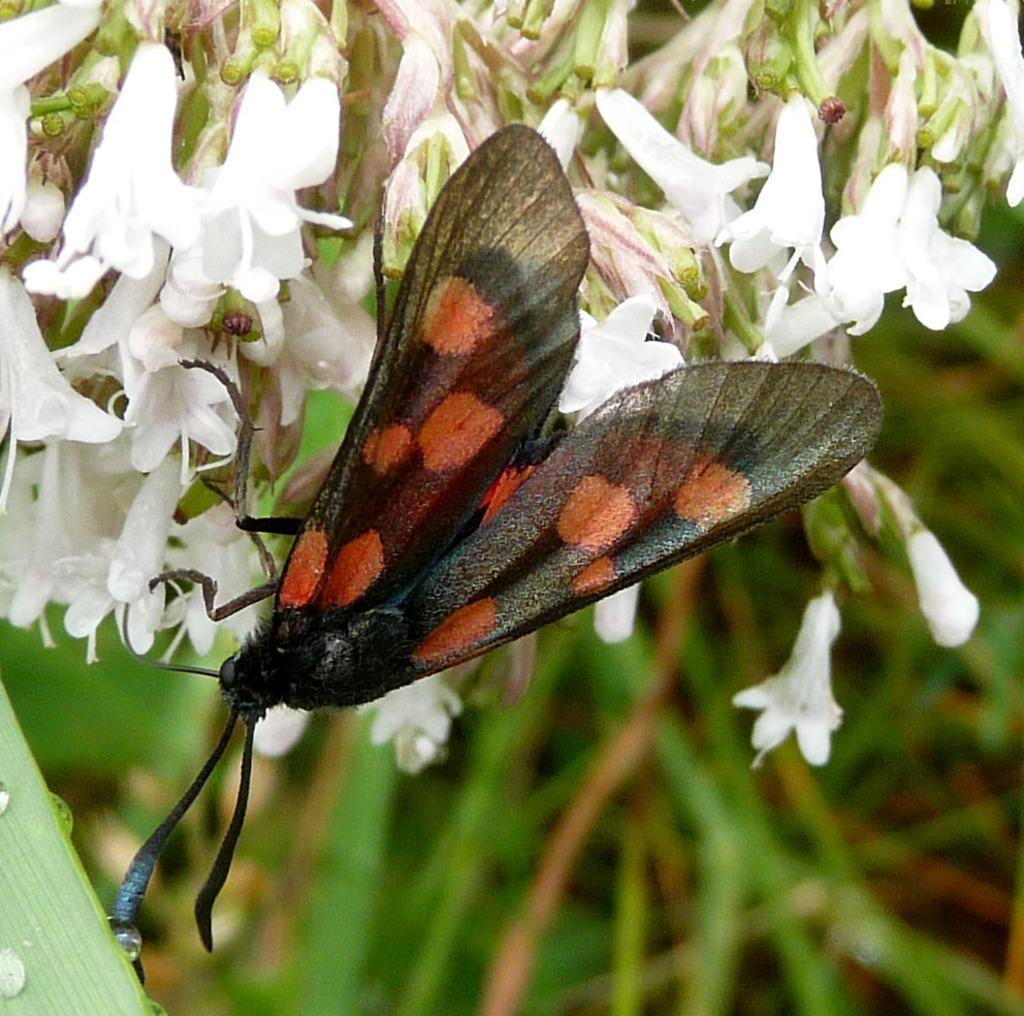In one or two sentences, can you explain what this image depicts? In this image we can see fly on a flower. 